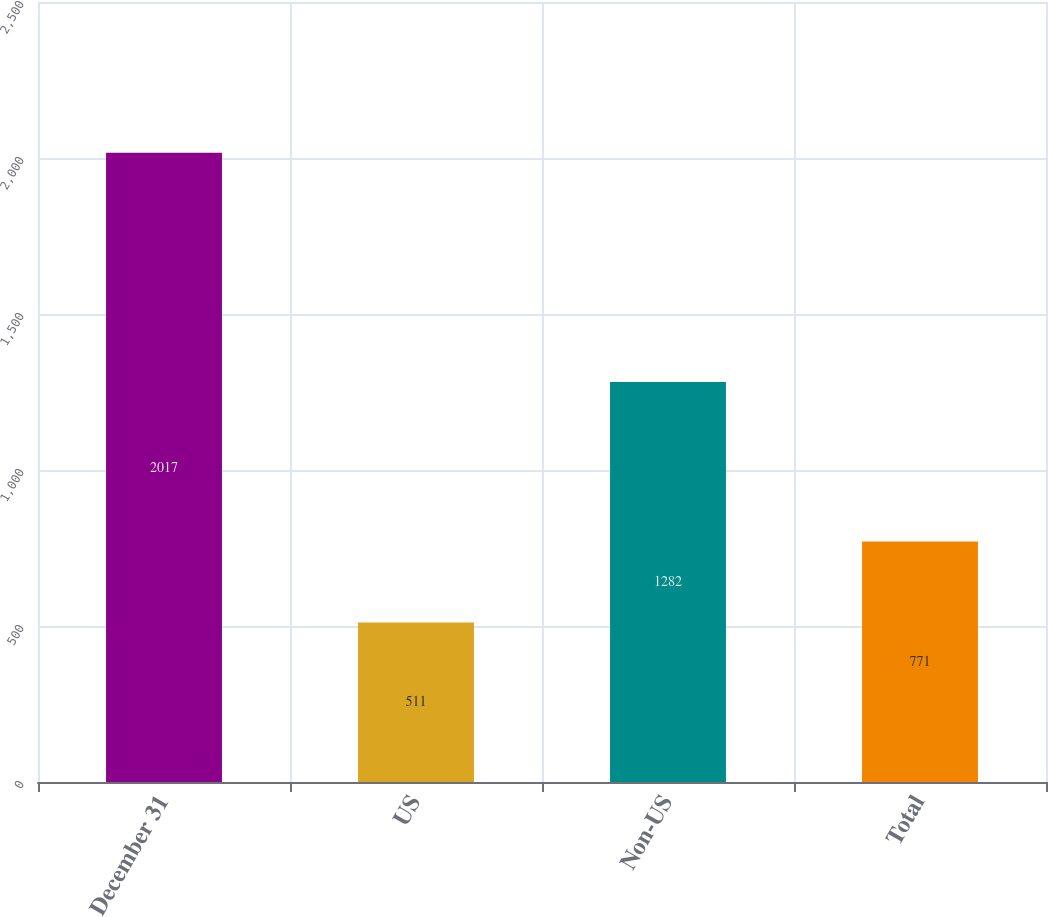Convert chart to OTSL. <chart><loc_0><loc_0><loc_500><loc_500><bar_chart><fcel>December 31<fcel>US<fcel>Non-US<fcel>Total<nl><fcel>2017<fcel>511<fcel>1282<fcel>771<nl></chart> 